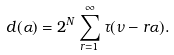Convert formula to latex. <formula><loc_0><loc_0><loc_500><loc_500>d ( \alpha ) = 2 ^ { N } \sum _ { r = 1 } ^ { \infty } \tau ( \nu - r \alpha ) .</formula> 